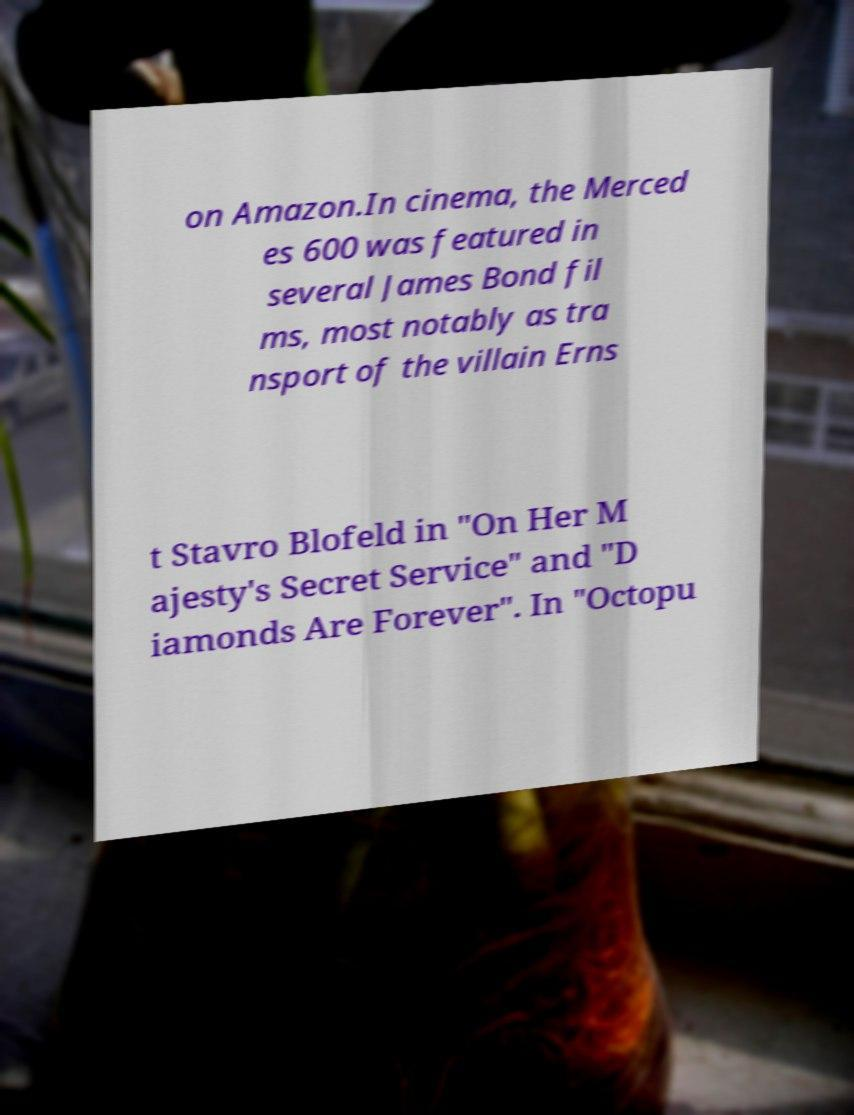I need the written content from this picture converted into text. Can you do that? on Amazon.In cinema, the Merced es 600 was featured in several James Bond fil ms, most notably as tra nsport of the villain Erns t Stavro Blofeld in "On Her M ajesty's Secret Service" and "D iamonds Are Forever". In "Octopu 